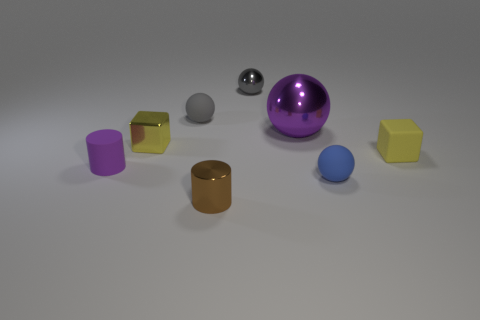Add 1 small metallic things. How many objects exist? 9 Subtract all purple spheres. Subtract all gray cylinders. How many spheres are left? 3 Subtract all cylinders. How many objects are left? 6 Add 2 yellow metallic cubes. How many yellow metallic cubes exist? 3 Subtract 0 cyan spheres. How many objects are left? 8 Subtract all metal balls. Subtract all blue matte balls. How many objects are left? 5 Add 1 small gray metal objects. How many small gray metal objects are left? 2 